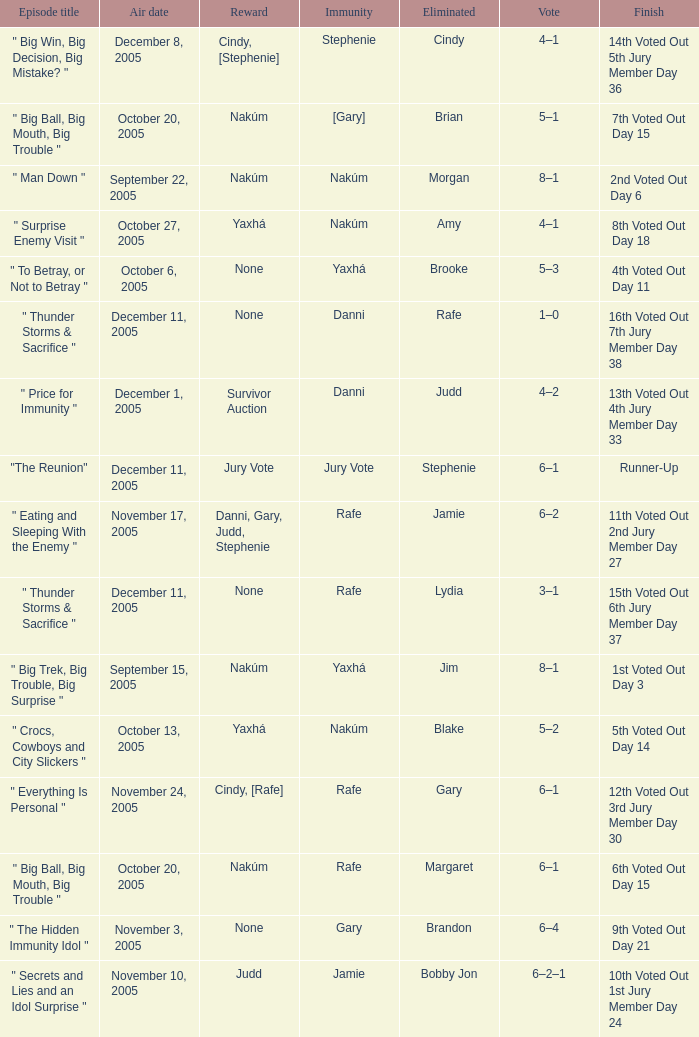How many air dates were there when Morgan was eliminated? 1.0. 